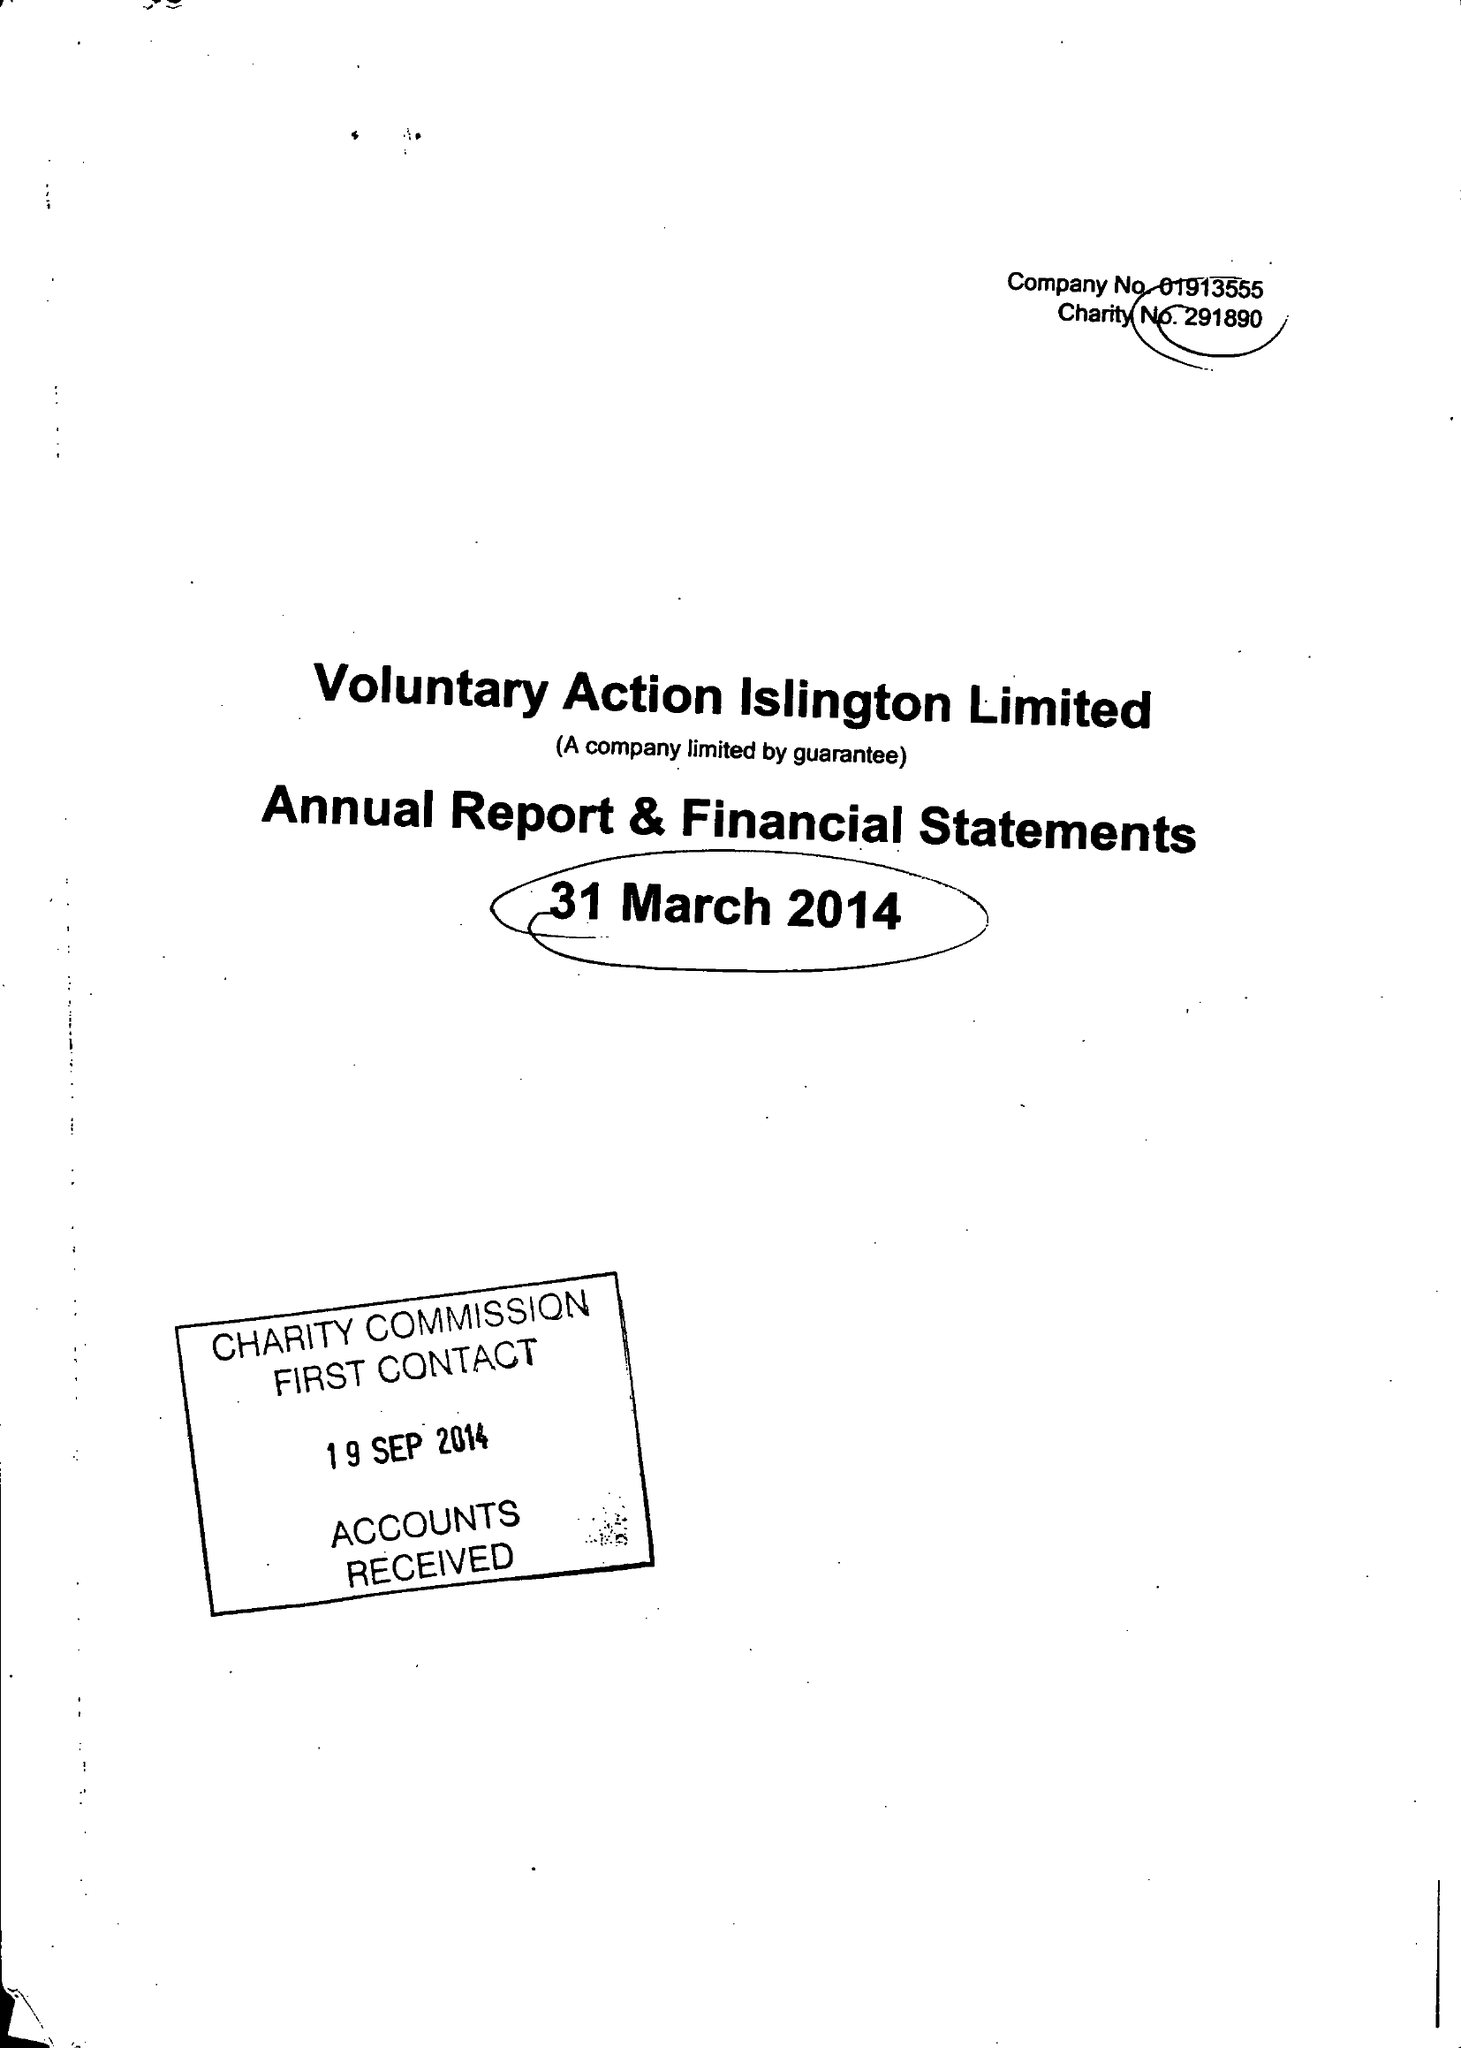What is the value for the address__postcode?
Answer the question using a single word or phrase. N1 9JP 